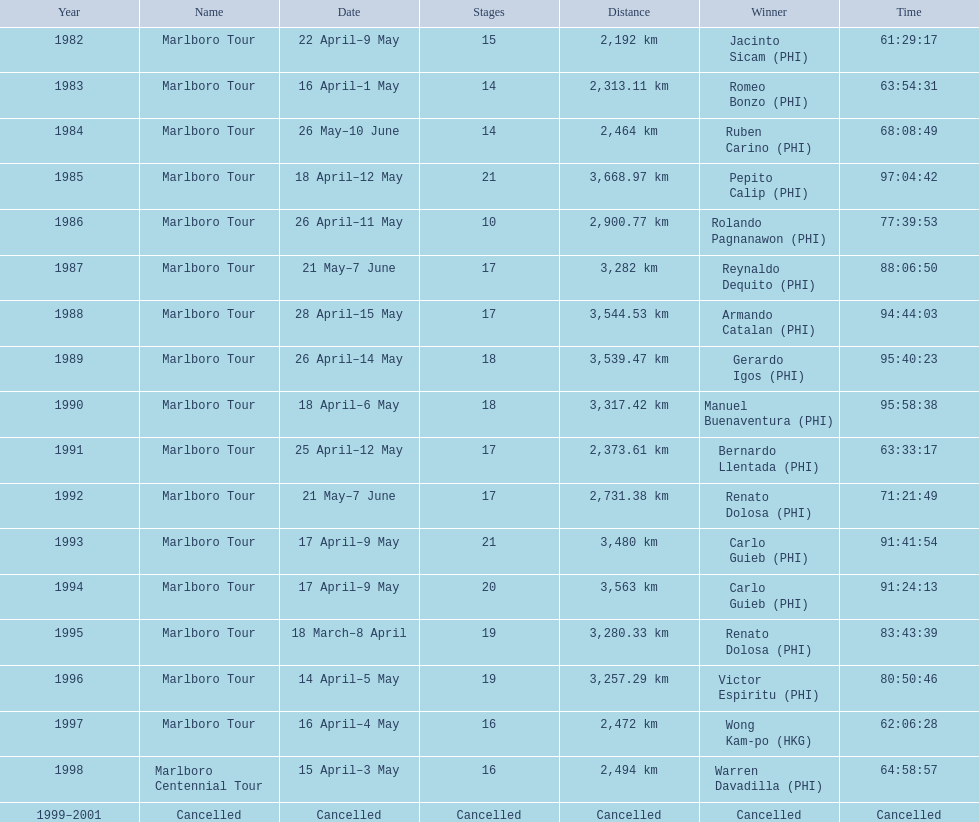What race did warren davadilla compete in in 1998? Marlboro Centennial Tour. How long did it take davadilla to complete the marlboro centennial tour? 64:58:57. 